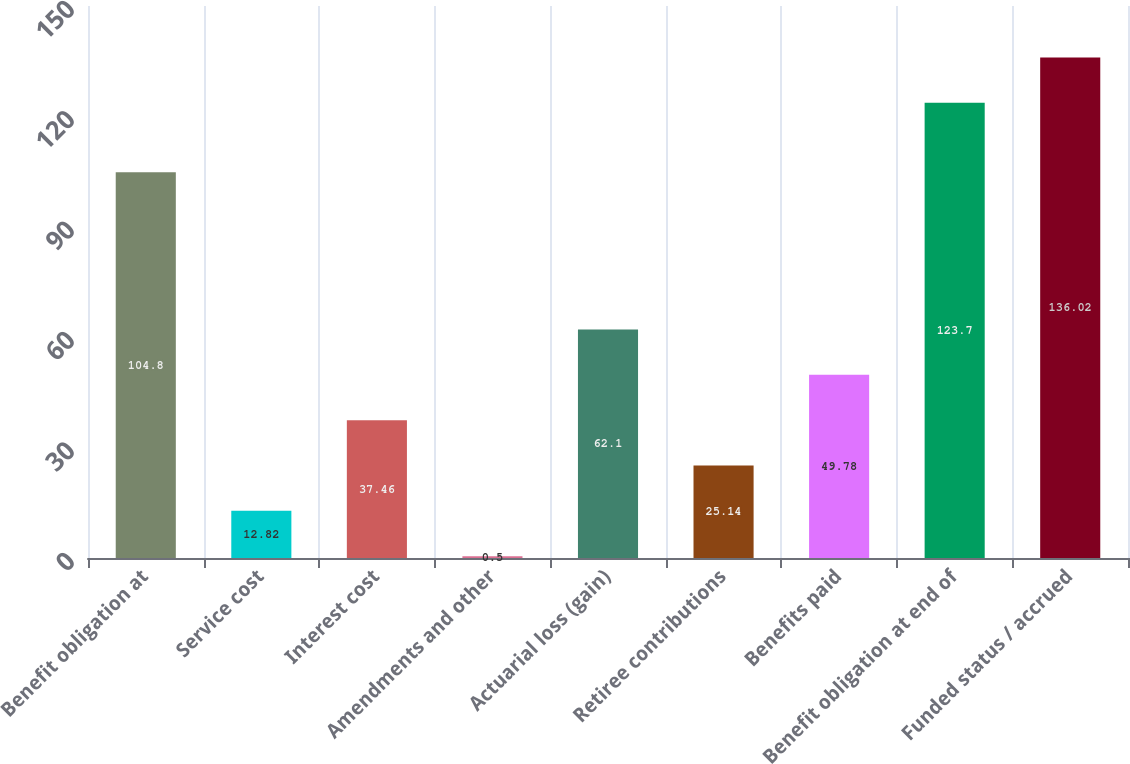Convert chart to OTSL. <chart><loc_0><loc_0><loc_500><loc_500><bar_chart><fcel>Benefit obligation at<fcel>Service cost<fcel>Interest cost<fcel>Amendments and other<fcel>Actuarial loss (gain)<fcel>Retiree contributions<fcel>Benefits paid<fcel>Benefit obligation at end of<fcel>Funded status / accrued<nl><fcel>104.8<fcel>12.82<fcel>37.46<fcel>0.5<fcel>62.1<fcel>25.14<fcel>49.78<fcel>123.7<fcel>136.02<nl></chart> 